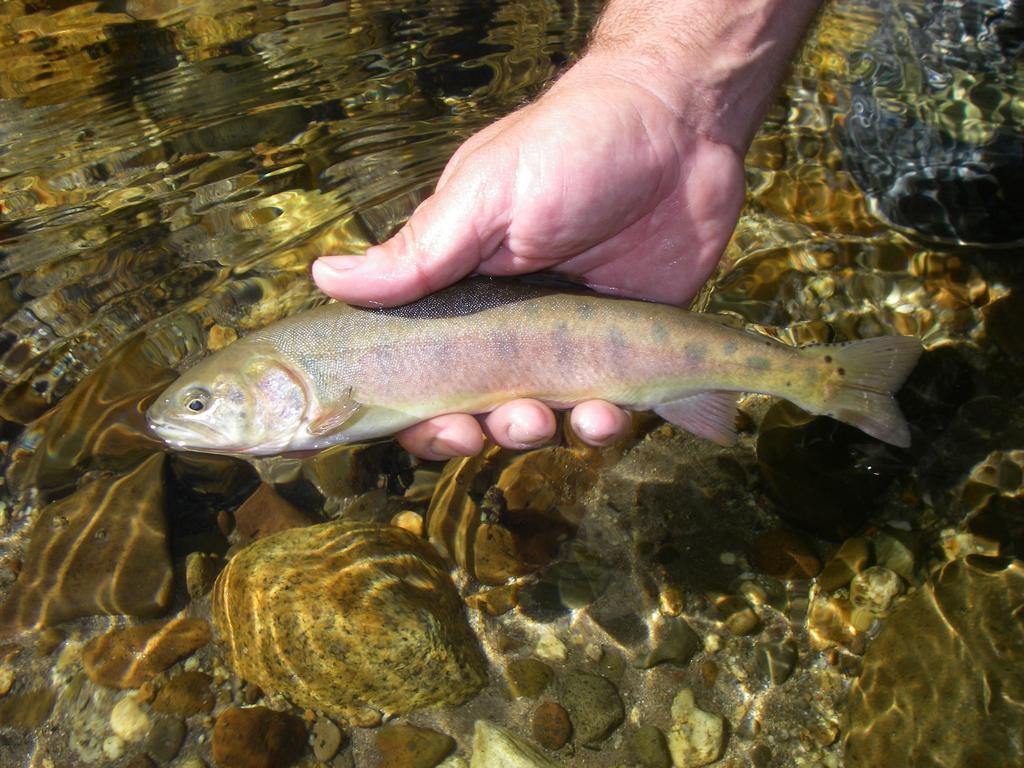How would you summarize this image in a sentence or two? This is a fish in the hand of a human and this is water. 